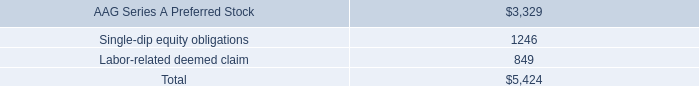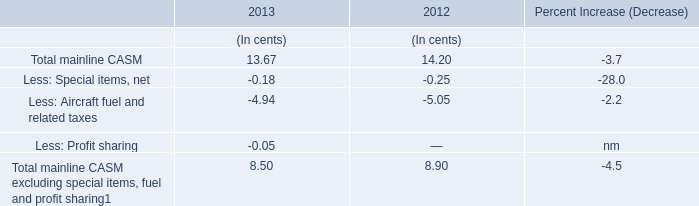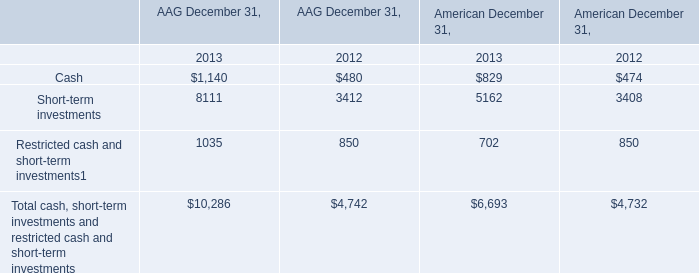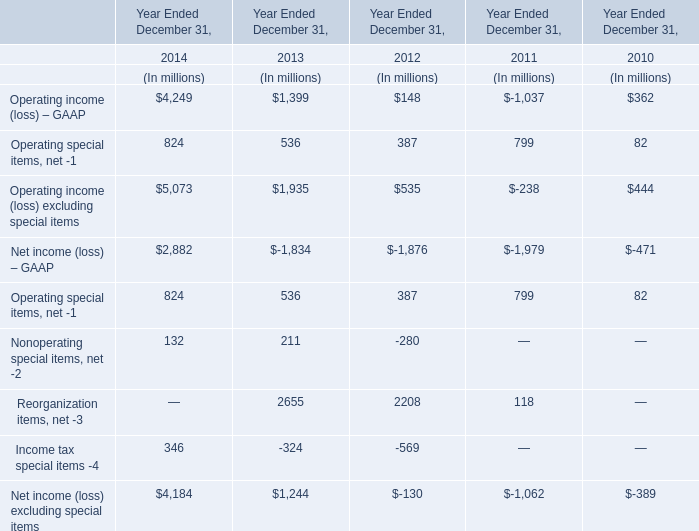In the year with the most Total mainline CASM in Table 1, what is the growth rate of Reorganization items, net -3 in Table 3? 
Computations: ((2208 - 118) / 118)
Answer: 17.71186. 